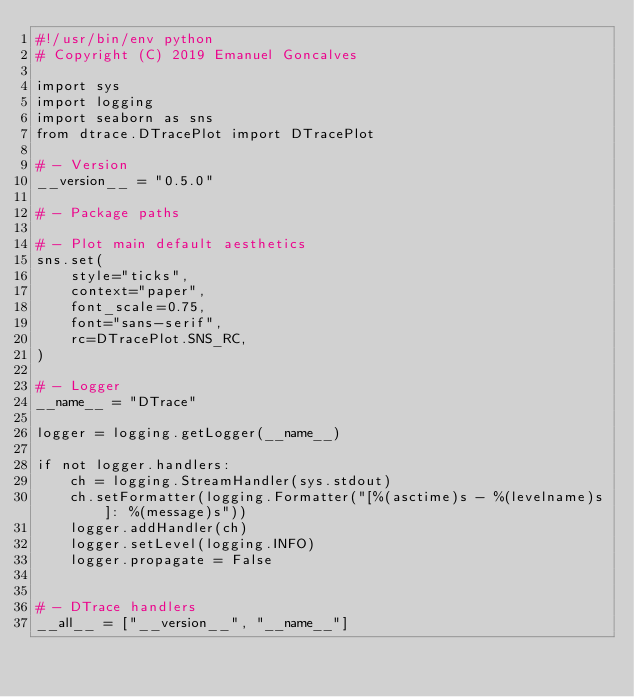<code> <loc_0><loc_0><loc_500><loc_500><_Python_>#!/usr/bin/env python
# Copyright (C) 2019 Emanuel Goncalves

import sys
import logging
import seaborn as sns
from dtrace.DTracePlot import DTracePlot

# - Version
__version__ = "0.5.0"

# - Package paths

# - Plot main default aesthetics
sns.set(
    style="ticks",
    context="paper",
    font_scale=0.75,
    font="sans-serif",
    rc=DTracePlot.SNS_RC,
)

# - Logger
__name__ = "DTrace"

logger = logging.getLogger(__name__)

if not logger.handlers:
    ch = logging.StreamHandler(sys.stdout)
    ch.setFormatter(logging.Formatter("[%(asctime)s - %(levelname)s]: %(message)s"))
    logger.addHandler(ch)
    logger.setLevel(logging.INFO)
    logger.propagate = False


# - DTrace handlers
__all__ = ["__version__", "__name__"]
</code> 